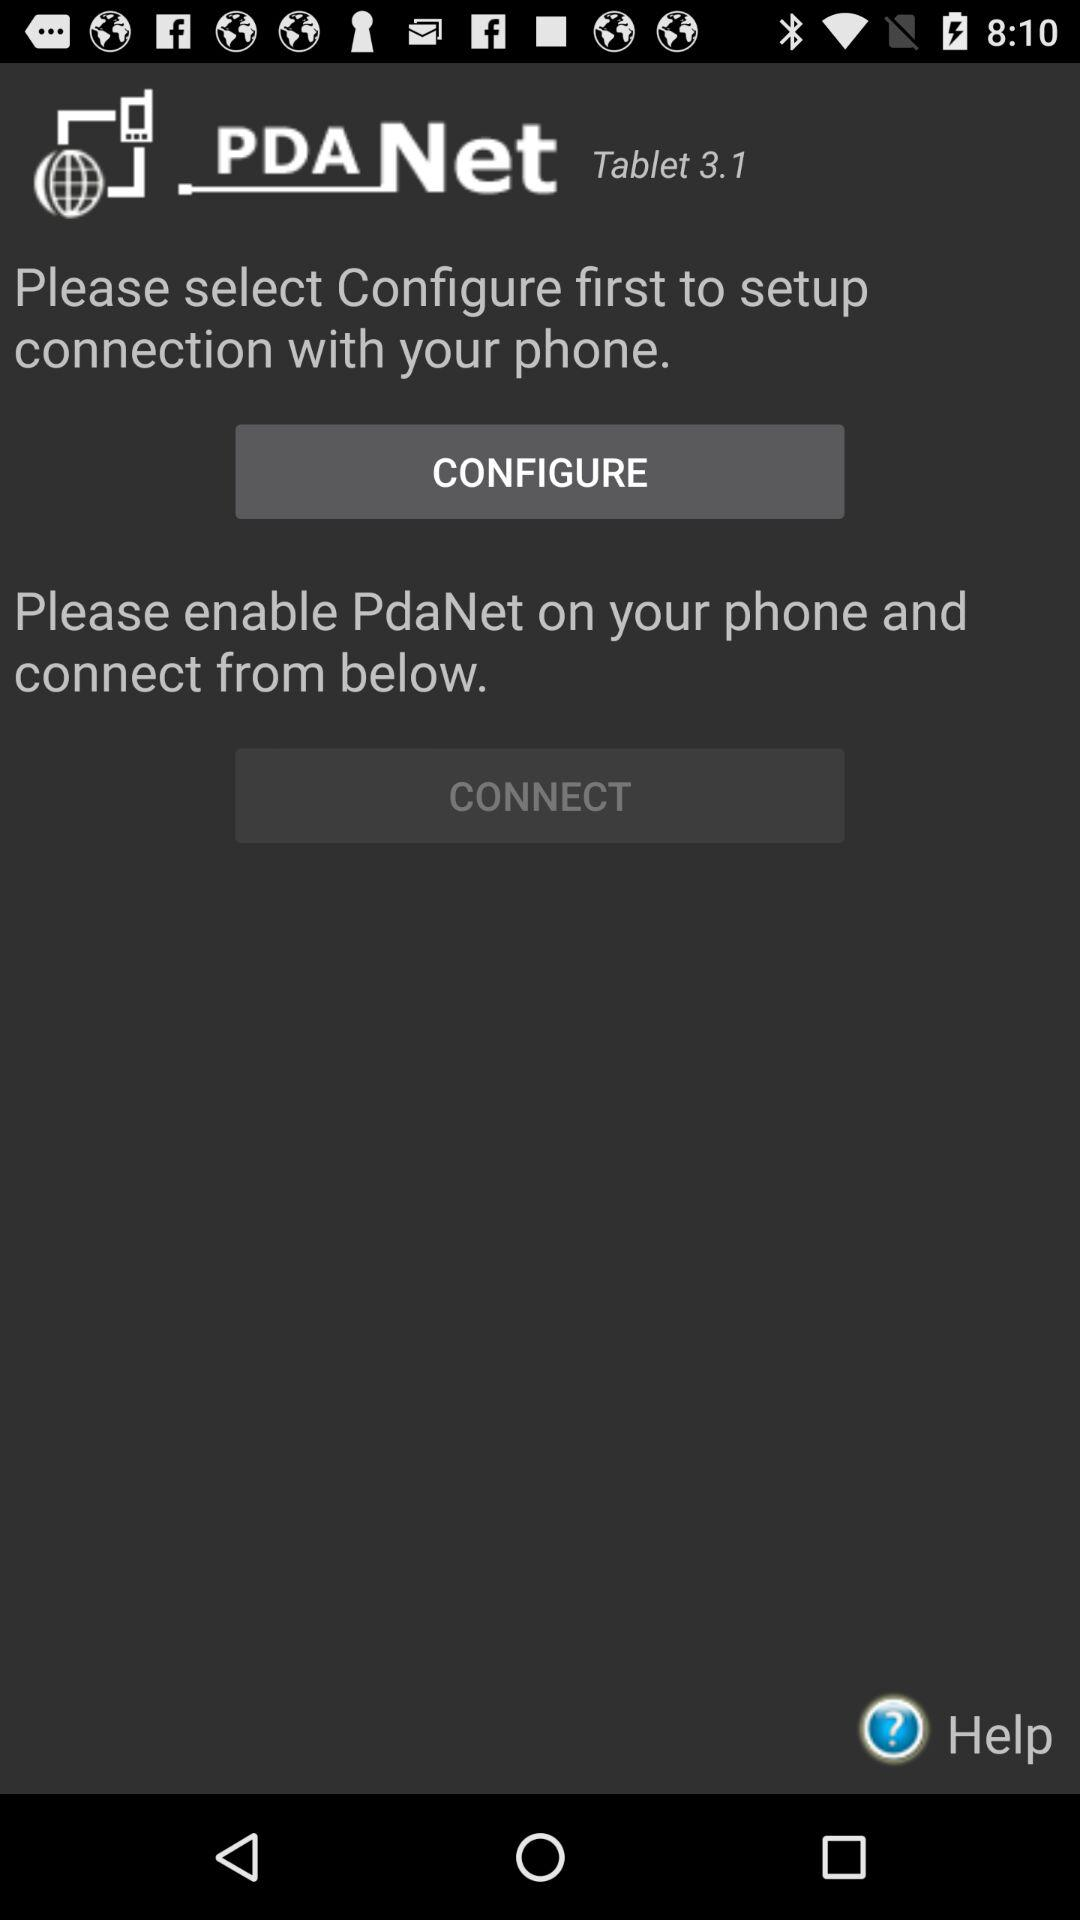What is the name of the application? The name of the application is "PdaNet". 